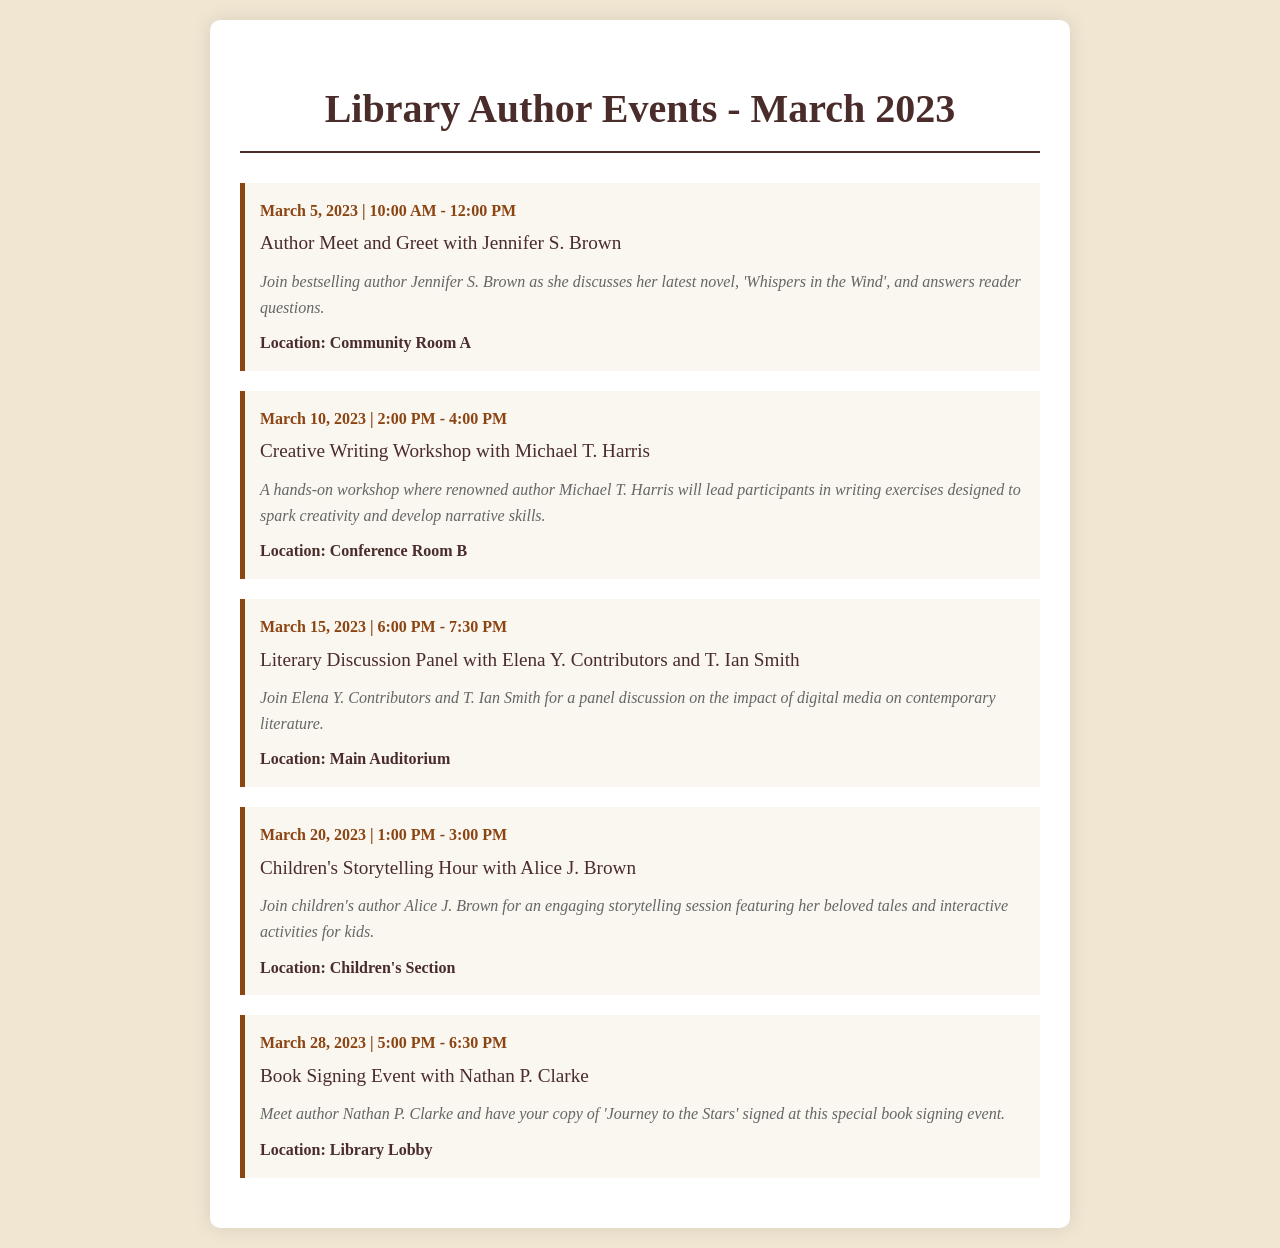Who is hosting the Creative Writing Workshop? The Creative Writing Workshop is hosted by renowned author Michael T. Harris.
Answer: Michael T. Harris What is the location of the Children's Storytelling Hour? The Children's Storytelling Hour will take place in the Children's Section.
Answer: Children's Section What is the main topic of the Literary Discussion Panel? The main topic of the Literary Discussion Panel is the impact of digital media on contemporary literature.
Answer: Impact of digital media on contemporary literature How many events are listed in the schedule? There are five events listed in the schedule for March 2023.
Answer: Five What type of event is taking place on March 20, 2023? The event on March 20, 2023, is a Children's Storytelling Hour.
Answer: Children's Storytelling Hour Where is the Book Signing Event taking place? The Book Signing Event is taking place in the Library Lobby.
Answer: Library Lobby What genre does Jennifer S. Brown write in? Jennifer S. Brown is a bestselling author known for her novels.
Answer: Novels 